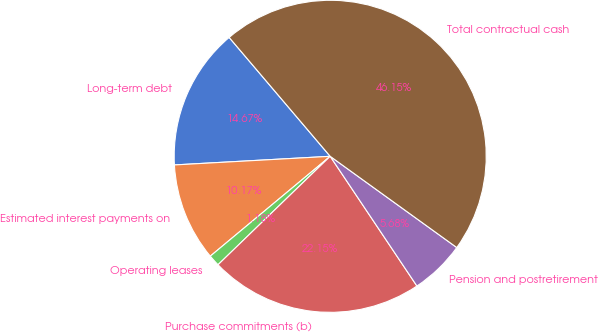Convert chart. <chart><loc_0><loc_0><loc_500><loc_500><pie_chart><fcel>Long-term debt<fcel>Estimated interest payments on<fcel>Operating leases<fcel>Purchase commitments (b)<fcel>Pension and postretirement<fcel>Total contractual cash<nl><fcel>14.67%<fcel>10.17%<fcel>1.18%<fcel>22.15%<fcel>5.68%<fcel>46.15%<nl></chart> 